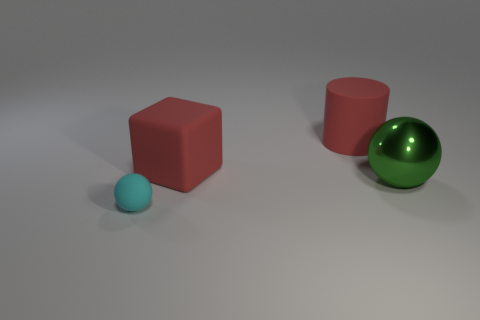Add 2 tiny balls. How many objects exist? 6 Subtract all cubes. How many objects are left? 3 Subtract all large cylinders. Subtract all green metal things. How many objects are left? 2 Add 2 green shiny balls. How many green shiny balls are left? 3 Add 2 tiny gray rubber spheres. How many tiny gray rubber spheres exist? 2 Subtract 0 cyan blocks. How many objects are left? 4 